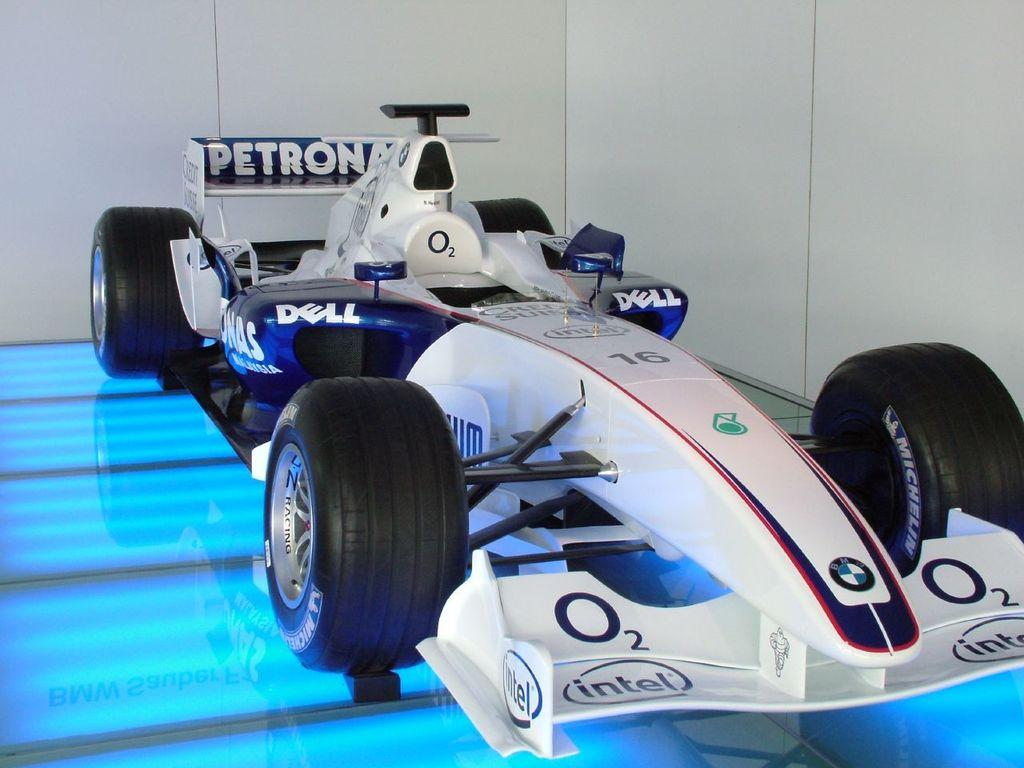What is the main subject of the image? The main subject of the image is a racing car. How does the hand of the driver look like in the image? There is no hand or driver visible in the image; it only features a racing car. 